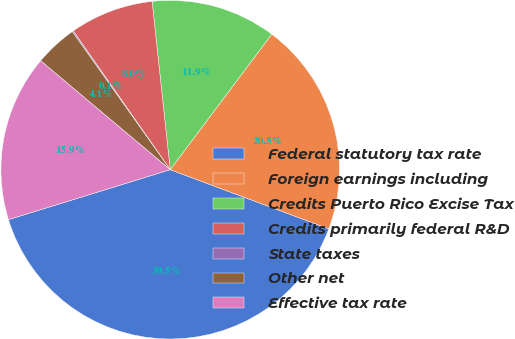Convert chart. <chart><loc_0><loc_0><loc_500><loc_500><pie_chart><fcel>Federal statutory tax rate<fcel>Foreign earnings including<fcel>Credits Puerto Rico Excise Tax<fcel>Credits primarily federal R&D<fcel>State taxes<fcel>Other net<fcel>Effective tax rate<nl><fcel>39.55%<fcel>20.45%<fcel>11.94%<fcel>8.0%<fcel>0.11%<fcel>4.06%<fcel>15.89%<nl></chart> 